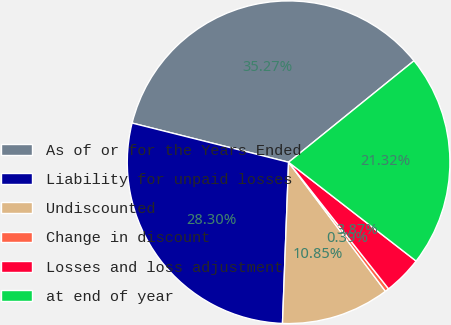Convert chart. <chart><loc_0><loc_0><loc_500><loc_500><pie_chart><fcel>As of or for the Years Ended<fcel>Liability for unpaid losses<fcel>Undiscounted<fcel>Change in discount<fcel>Losses and loss adjustment<fcel>at end of year<nl><fcel>35.27%<fcel>28.3%<fcel>10.85%<fcel>0.39%<fcel>3.87%<fcel>21.32%<nl></chart> 